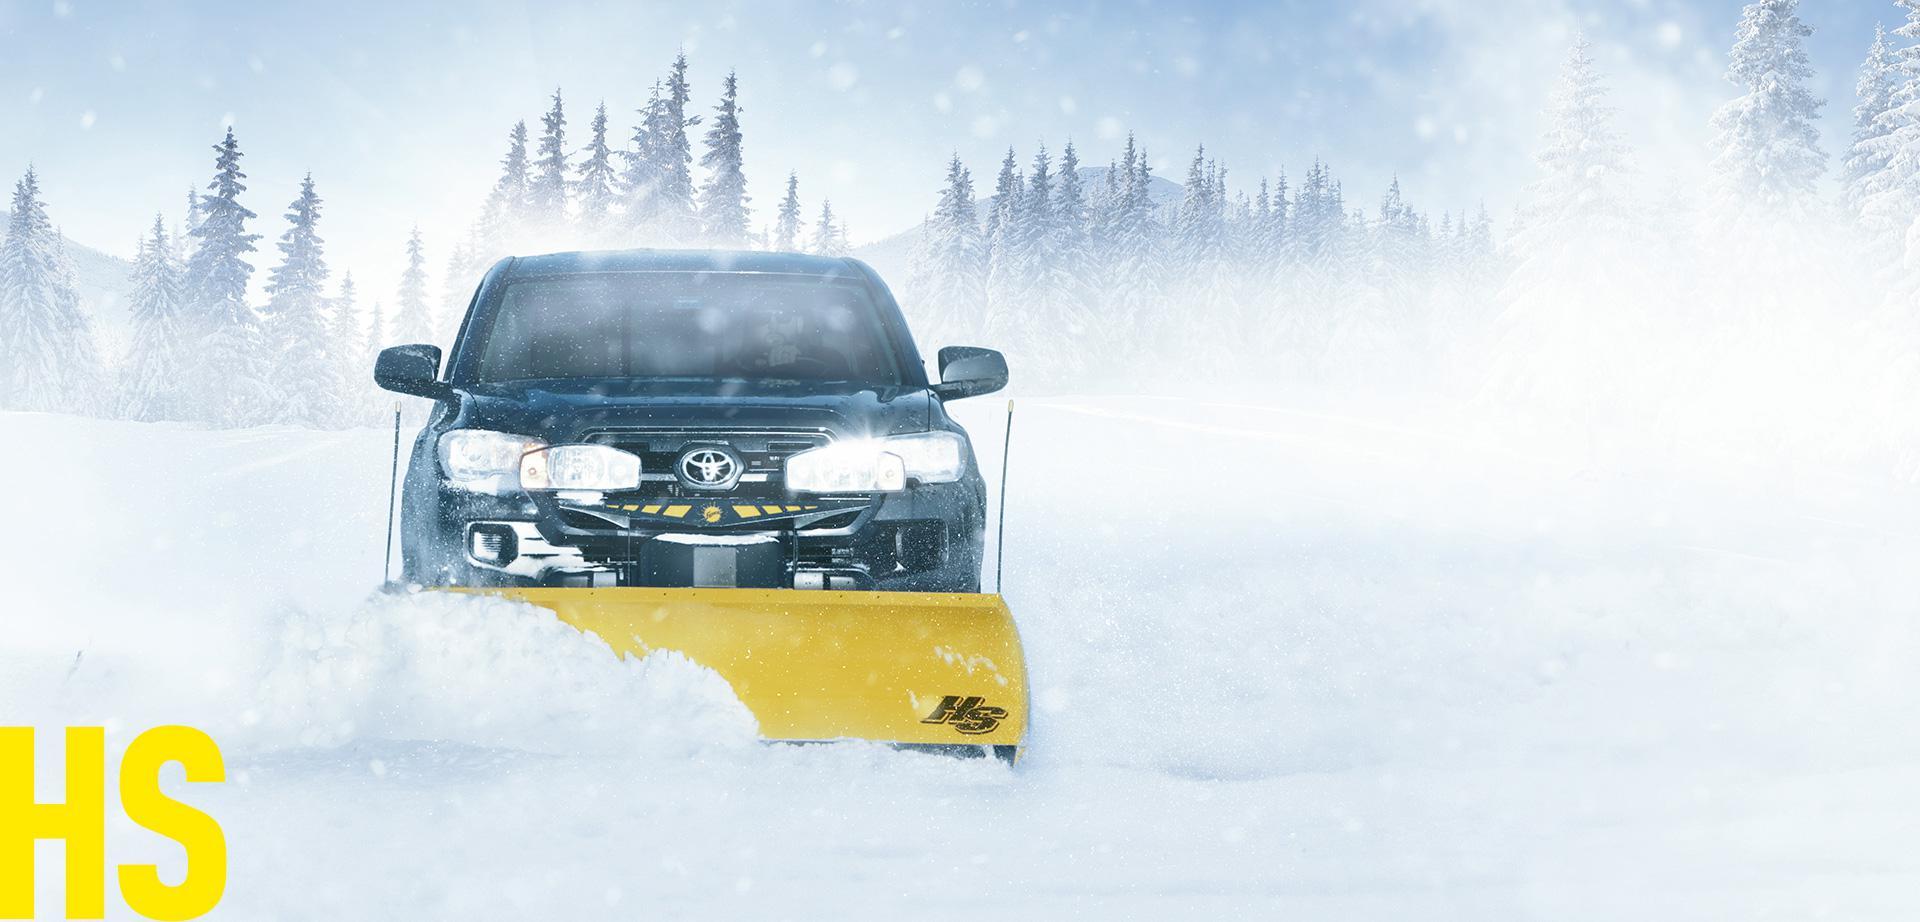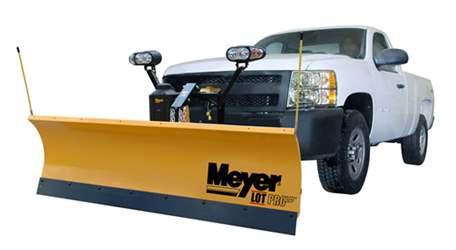The first image is the image on the left, the second image is the image on the right. Analyze the images presented: Is the assertion "Left image shows a camera-facing vehicle plowing a snow-covered ground." valid? Answer yes or no. Yes. The first image is the image on the left, the second image is the image on the right. Examine the images to the left and right. Is the description "A pile of snow is being bulldozed by a vehicle." accurate? Answer yes or no. Yes. 